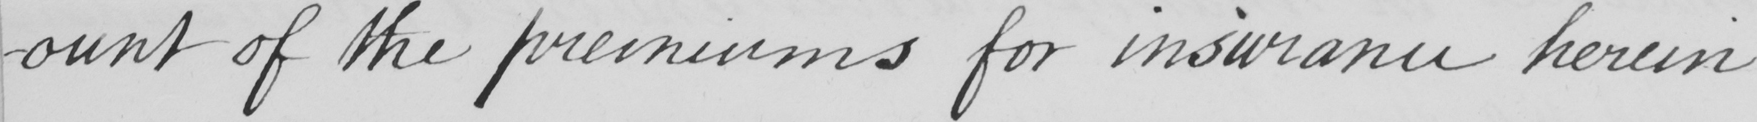What text is written in this handwritten line? -ount of the premiums for insurance herein 